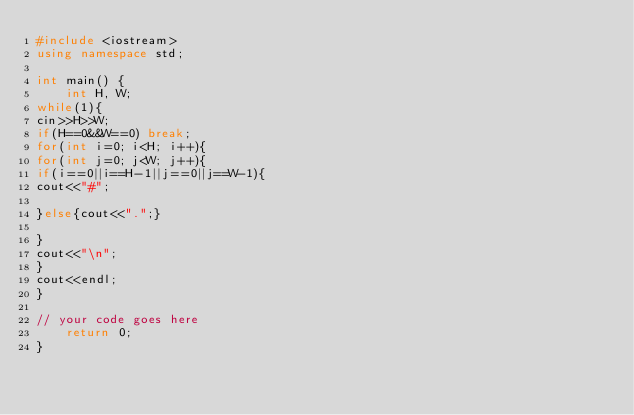Convert code to text. <code><loc_0><loc_0><loc_500><loc_500><_C++_>#include <iostream>
using namespace std;

int main() {
	int H, W;
while(1){
cin>>H>>W;
if(H==0&&W==0) break;
for(int i=0; i<H; i++){
for(int j=0; j<W; j++){
if(i==0||i==H-1||j==0||j==W-1){
cout<<"#";

}else{cout<<".";}

}
cout<<"\n";
}
cout<<endl;
}

// your code goes here
	return 0;
}</code> 